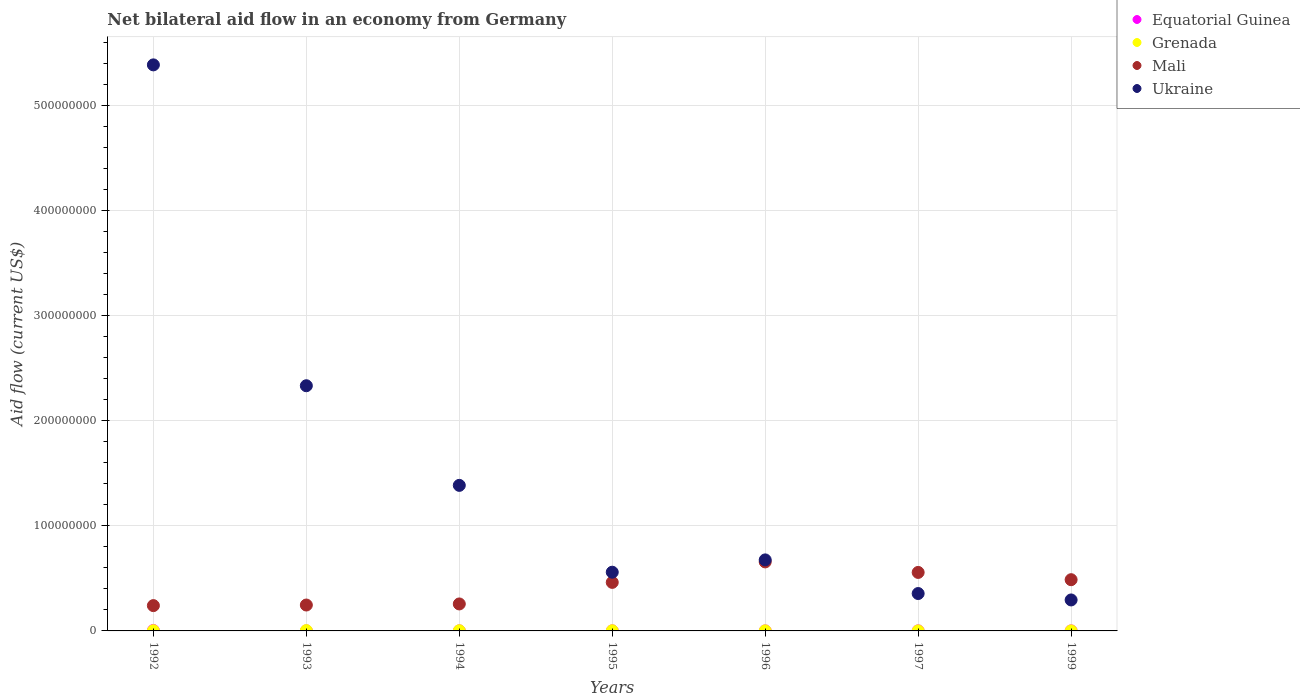Is the number of dotlines equal to the number of legend labels?
Ensure brevity in your answer.  Yes. What is the net bilateral aid flow in Equatorial Guinea in 1992?
Provide a short and direct response. 4.50e+05. In which year was the net bilateral aid flow in Ukraine minimum?
Provide a succinct answer. 1999. What is the total net bilateral aid flow in Ukraine in the graph?
Give a very brief answer. 1.10e+09. What is the difference between the net bilateral aid flow in Mali in 1992 and that in 1995?
Offer a very short reply. -2.21e+07. What is the difference between the net bilateral aid flow in Ukraine in 1994 and the net bilateral aid flow in Equatorial Guinea in 1996?
Give a very brief answer. 1.39e+08. What is the average net bilateral aid flow in Ukraine per year?
Your response must be concise. 1.57e+08. In the year 1993, what is the difference between the net bilateral aid flow in Equatorial Guinea and net bilateral aid flow in Mali?
Provide a succinct answer. -2.46e+07. In how many years, is the net bilateral aid flow in Equatorial Guinea greater than 380000000 US$?
Ensure brevity in your answer.  0. Is the difference between the net bilateral aid flow in Equatorial Guinea in 1994 and 1997 greater than the difference between the net bilateral aid flow in Mali in 1994 and 1997?
Give a very brief answer. Yes. What is the difference between the highest and the second highest net bilateral aid flow in Ukraine?
Your response must be concise. 3.05e+08. What is the difference between the highest and the lowest net bilateral aid flow in Ukraine?
Your response must be concise. 5.09e+08. In how many years, is the net bilateral aid flow in Ukraine greater than the average net bilateral aid flow in Ukraine taken over all years?
Ensure brevity in your answer.  2. Is it the case that in every year, the sum of the net bilateral aid flow in Equatorial Guinea and net bilateral aid flow in Mali  is greater than the sum of net bilateral aid flow in Grenada and net bilateral aid flow in Ukraine?
Provide a short and direct response. No. Does the net bilateral aid flow in Ukraine monotonically increase over the years?
Offer a very short reply. No. Is the net bilateral aid flow in Ukraine strictly less than the net bilateral aid flow in Equatorial Guinea over the years?
Make the answer very short. No. How many years are there in the graph?
Keep it short and to the point. 7. What is the difference between two consecutive major ticks on the Y-axis?
Offer a terse response. 1.00e+08. Where does the legend appear in the graph?
Give a very brief answer. Top right. What is the title of the graph?
Provide a short and direct response. Net bilateral aid flow in an economy from Germany. Does "Tajikistan" appear as one of the legend labels in the graph?
Your answer should be very brief. No. What is the Aid flow (current US$) in Mali in 1992?
Offer a very short reply. 2.41e+07. What is the Aid flow (current US$) in Ukraine in 1992?
Provide a short and direct response. 5.39e+08. What is the Aid flow (current US$) in Equatorial Guinea in 1993?
Provide a short and direct response. 5.00e+04. What is the Aid flow (current US$) of Grenada in 1993?
Provide a short and direct response. 3.10e+05. What is the Aid flow (current US$) of Mali in 1993?
Your response must be concise. 2.46e+07. What is the Aid flow (current US$) in Ukraine in 1993?
Offer a terse response. 2.33e+08. What is the Aid flow (current US$) in Equatorial Guinea in 1994?
Ensure brevity in your answer.  6.00e+04. What is the Aid flow (current US$) of Grenada in 1994?
Offer a terse response. 1.90e+05. What is the Aid flow (current US$) in Mali in 1994?
Make the answer very short. 2.57e+07. What is the Aid flow (current US$) of Ukraine in 1994?
Keep it short and to the point. 1.39e+08. What is the Aid flow (current US$) in Grenada in 1995?
Keep it short and to the point. 1.70e+05. What is the Aid flow (current US$) of Mali in 1995?
Your answer should be very brief. 4.62e+07. What is the Aid flow (current US$) in Ukraine in 1995?
Make the answer very short. 5.59e+07. What is the Aid flow (current US$) in Mali in 1996?
Your answer should be compact. 6.57e+07. What is the Aid flow (current US$) of Ukraine in 1996?
Give a very brief answer. 6.76e+07. What is the Aid flow (current US$) of Equatorial Guinea in 1997?
Make the answer very short. 7.00e+04. What is the Aid flow (current US$) of Grenada in 1997?
Your answer should be very brief. 3.00e+04. What is the Aid flow (current US$) in Mali in 1997?
Your response must be concise. 5.57e+07. What is the Aid flow (current US$) in Ukraine in 1997?
Offer a terse response. 3.56e+07. What is the Aid flow (current US$) in Mali in 1999?
Give a very brief answer. 4.88e+07. What is the Aid flow (current US$) in Ukraine in 1999?
Offer a very short reply. 2.95e+07. Across all years, what is the maximum Aid flow (current US$) of Grenada?
Your answer should be compact. 3.10e+05. Across all years, what is the maximum Aid flow (current US$) in Mali?
Make the answer very short. 6.57e+07. Across all years, what is the maximum Aid flow (current US$) in Ukraine?
Make the answer very short. 5.39e+08. Across all years, what is the minimum Aid flow (current US$) in Equatorial Guinea?
Your response must be concise. 3.00e+04. Across all years, what is the minimum Aid flow (current US$) in Mali?
Your answer should be compact. 2.41e+07. Across all years, what is the minimum Aid flow (current US$) in Ukraine?
Your answer should be very brief. 2.95e+07. What is the total Aid flow (current US$) in Equatorial Guinea in the graph?
Give a very brief answer. 7.90e+05. What is the total Aid flow (current US$) in Grenada in the graph?
Keep it short and to the point. 1.00e+06. What is the total Aid flow (current US$) of Mali in the graph?
Offer a very short reply. 2.91e+08. What is the total Aid flow (current US$) in Ukraine in the graph?
Offer a terse response. 1.10e+09. What is the difference between the Aid flow (current US$) of Mali in 1992 and that in 1993?
Your answer should be very brief. -5.60e+05. What is the difference between the Aid flow (current US$) in Ukraine in 1992 and that in 1993?
Your response must be concise. 3.05e+08. What is the difference between the Aid flow (current US$) of Equatorial Guinea in 1992 and that in 1994?
Give a very brief answer. 3.90e+05. What is the difference between the Aid flow (current US$) of Mali in 1992 and that in 1994?
Your answer should be very brief. -1.59e+06. What is the difference between the Aid flow (current US$) in Ukraine in 1992 and that in 1994?
Make the answer very short. 4.00e+08. What is the difference between the Aid flow (current US$) of Equatorial Guinea in 1992 and that in 1995?
Offer a very short reply. 3.80e+05. What is the difference between the Aid flow (current US$) of Grenada in 1992 and that in 1995?
Keep it short and to the point. 3.00e+04. What is the difference between the Aid flow (current US$) in Mali in 1992 and that in 1995?
Give a very brief answer. -2.21e+07. What is the difference between the Aid flow (current US$) in Ukraine in 1992 and that in 1995?
Provide a succinct answer. 4.83e+08. What is the difference between the Aid flow (current US$) of Mali in 1992 and that in 1996?
Ensure brevity in your answer.  -4.16e+07. What is the difference between the Aid flow (current US$) of Ukraine in 1992 and that in 1996?
Your response must be concise. 4.71e+08. What is the difference between the Aid flow (current US$) of Mali in 1992 and that in 1997?
Ensure brevity in your answer.  -3.16e+07. What is the difference between the Aid flow (current US$) in Ukraine in 1992 and that in 1997?
Ensure brevity in your answer.  5.03e+08. What is the difference between the Aid flow (current US$) in Equatorial Guinea in 1992 and that in 1999?
Make the answer very short. 3.90e+05. What is the difference between the Aid flow (current US$) in Mali in 1992 and that in 1999?
Provide a short and direct response. -2.47e+07. What is the difference between the Aid flow (current US$) of Ukraine in 1992 and that in 1999?
Offer a very short reply. 5.09e+08. What is the difference between the Aid flow (current US$) in Equatorial Guinea in 1993 and that in 1994?
Give a very brief answer. -10000. What is the difference between the Aid flow (current US$) in Mali in 1993 and that in 1994?
Your response must be concise. -1.03e+06. What is the difference between the Aid flow (current US$) of Ukraine in 1993 and that in 1994?
Keep it short and to the point. 9.48e+07. What is the difference between the Aid flow (current US$) in Equatorial Guinea in 1993 and that in 1995?
Offer a very short reply. -2.00e+04. What is the difference between the Aid flow (current US$) of Grenada in 1993 and that in 1995?
Provide a succinct answer. 1.40e+05. What is the difference between the Aid flow (current US$) in Mali in 1993 and that in 1995?
Keep it short and to the point. -2.16e+07. What is the difference between the Aid flow (current US$) in Ukraine in 1993 and that in 1995?
Keep it short and to the point. 1.77e+08. What is the difference between the Aid flow (current US$) in Equatorial Guinea in 1993 and that in 1996?
Offer a terse response. 2.00e+04. What is the difference between the Aid flow (current US$) of Grenada in 1993 and that in 1996?
Offer a terse response. 2.40e+05. What is the difference between the Aid flow (current US$) in Mali in 1993 and that in 1996?
Provide a succinct answer. -4.10e+07. What is the difference between the Aid flow (current US$) in Ukraine in 1993 and that in 1996?
Your response must be concise. 1.66e+08. What is the difference between the Aid flow (current US$) of Equatorial Guinea in 1993 and that in 1997?
Offer a terse response. -2.00e+04. What is the difference between the Aid flow (current US$) in Grenada in 1993 and that in 1997?
Keep it short and to the point. 2.80e+05. What is the difference between the Aid flow (current US$) of Mali in 1993 and that in 1997?
Keep it short and to the point. -3.10e+07. What is the difference between the Aid flow (current US$) of Ukraine in 1993 and that in 1997?
Make the answer very short. 1.98e+08. What is the difference between the Aid flow (current US$) in Grenada in 1993 and that in 1999?
Give a very brief answer. 2.80e+05. What is the difference between the Aid flow (current US$) in Mali in 1993 and that in 1999?
Your answer should be very brief. -2.41e+07. What is the difference between the Aid flow (current US$) in Ukraine in 1993 and that in 1999?
Offer a very short reply. 2.04e+08. What is the difference between the Aid flow (current US$) in Mali in 1994 and that in 1995?
Give a very brief answer. -2.05e+07. What is the difference between the Aid flow (current US$) of Ukraine in 1994 and that in 1995?
Your answer should be compact. 8.27e+07. What is the difference between the Aid flow (current US$) in Equatorial Guinea in 1994 and that in 1996?
Your answer should be compact. 3.00e+04. What is the difference between the Aid flow (current US$) in Mali in 1994 and that in 1996?
Your answer should be compact. -4.00e+07. What is the difference between the Aid flow (current US$) in Ukraine in 1994 and that in 1996?
Keep it short and to the point. 7.09e+07. What is the difference between the Aid flow (current US$) in Mali in 1994 and that in 1997?
Offer a very short reply. -3.00e+07. What is the difference between the Aid flow (current US$) of Ukraine in 1994 and that in 1997?
Make the answer very short. 1.03e+08. What is the difference between the Aid flow (current US$) in Equatorial Guinea in 1994 and that in 1999?
Give a very brief answer. 0. What is the difference between the Aid flow (current US$) in Mali in 1994 and that in 1999?
Your response must be concise. -2.31e+07. What is the difference between the Aid flow (current US$) in Ukraine in 1994 and that in 1999?
Give a very brief answer. 1.09e+08. What is the difference between the Aid flow (current US$) in Equatorial Guinea in 1995 and that in 1996?
Your response must be concise. 4.00e+04. What is the difference between the Aid flow (current US$) in Mali in 1995 and that in 1996?
Offer a very short reply. -1.95e+07. What is the difference between the Aid flow (current US$) in Ukraine in 1995 and that in 1996?
Ensure brevity in your answer.  -1.17e+07. What is the difference between the Aid flow (current US$) of Equatorial Guinea in 1995 and that in 1997?
Keep it short and to the point. 0. What is the difference between the Aid flow (current US$) of Mali in 1995 and that in 1997?
Offer a terse response. -9.48e+06. What is the difference between the Aid flow (current US$) in Ukraine in 1995 and that in 1997?
Ensure brevity in your answer.  2.03e+07. What is the difference between the Aid flow (current US$) of Grenada in 1995 and that in 1999?
Offer a terse response. 1.40e+05. What is the difference between the Aid flow (current US$) in Mali in 1995 and that in 1999?
Your response must be concise. -2.56e+06. What is the difference between the Aid flow (current US$) in Ukraine in 1995 and that in 1999?
Offer a very short reply. 2.64e+07. What is the difference between the Aid flow (current US$) in Grenada in 1996 and that in 1997?
Ensure brevity in your answer.  4.00e+04. What is the difference between the Aid flow (current US$) in Mali in 1996 and that in 1997?
Offer a very short reply. 1.00e+07. What is the difference between the Aid flow (current US$) of Ukraine in 1996 and that in 1997?
Give a very brief answer. 3.20e+07. What is the difference between the Aid flow (current US$) of Equatorial Guinea in 1996 and that in 1999?
Provide a succinct answer. -3.00e+04. What is the difference between the Aid flow (current US$) of Grenada in 1996 and that in 1999?
Your answer should be compact. 4.00e+04. What is the difference between the Aid flow (current US$) in Mali in 1996 and that in 1999?
Keep it short and to the point. 1.69e+07. What is the difference between the Aid flow (current US$) in Ukraine in 1996 and that in 1999?
Offer a terse response. 3.81e+07. What is the difference between the Aid flow (current US$) in Equatorial Guinea in 1997 and that in 1999?
Provide a succinct answer. 10000. What is the difference between the Aid flow (current US$) in Grenada in 1997 and that in 1999?
Keep it short and to the point. 0. What is the difference between the Aid flow (current US$) in Mali in 1997 and that in 1999?
Offer a very short reply. 6.92e+06. What is the difference between the Aid flow (current US$) of Ukraine in 1997 and that in 1999?
Provide a short and direct response. 6.10e+06. What is the difference between the Aid flow (current US$) of Equatorial Guinea in 1992 and the Aid flow (current US$) of Grenada in 1993?
Offer a terse response. 1.40e+05. What is the difference between the Aid flow (current US$) in Equatorial Guinea in 1992 and the Aid flow (current US$) in Mali in 1993?
Keep it short and to the point. -2.42e+07. What is the difference between the Aid flow (current US$) in Equatorial Guinea in 1992 and the Aid flow (current US$) in Ukraine in 1993?
Provide a short and direct response. -2.33e+08. What is the difference between the Aid flow (current US$) in Grenada in 1992 and the Aid flow (current US$) in Mali in 1993?
Make the answer very short. -2.44e+07. What is the difference between the Aid flow (current US$) of Grenada in 1992 and the Aid flow (current US$) of Ukraine in 1993?
Provide a succinct answer. -2.33e+08. What is the difference between the Aid flow (current US$) of Mali in 1992 and the Aid flow (current US$) of Ukraine in 1993?
Give a very brief answer. -2.09e+08. What is the difference between the Aid flow (current US$) of Equatorial Guinea in 1992 and the Aid flow (current US$) of Mali in 1994?
Ensure brevity in your answer.  -2.52e+07. What is the difference between the Aid flow (current US$) in Equatorial Guinea in 1992 and the Aid flow (current US$) in Ukraine in 1994?
Make the answer very short. -1.38e+08. What is the difference between the Aid flow (current US$) of Grenada in 1992 and the Aid flow (current US$) of Mali in 1994?
Give a very brief answer. -2.55e+07. What is the difference between the Aid flow (current US$) of Grenada in 1992 and the Aid flow (current US$) of Ukraine in 1994?
Your answer should be very brief. -1.38e+08. What is the difference between the Aid flow (current US$) of Mali in 1992 and the Aid flow (current US$) of Ukraine in 1994?
Provide a short and direct response. -1.14e+08. What is the difference between the Aid flow (current US$) in Equatorial Guinea in 1992 and the Aid flow (current US$) in Grenada in 1995?
Provide a succinct answer. 2.80e+05. What is the difference between the Aid flow (current US$) of Equatorial Guinea in 1992 and the Aid flow (current US$) of Mali in 1995?
Provide a short and direct response. -4.58e+07. What is the difference between the Aid flow (current US$) of Equatorial Guinea in 1992 and the Aid flow (current US$) of Ukraine in 1995?
Your answer should be compact. -5.54e+07. What is the difference between the Aid flow (current US$) of Grenada in 1992 and the Aid flow (current US$) of Mali in 1995?
Offer a terse response. -4.60e+07. What is the difference between the Aid flow (current US$) of Grenada in 1992 and the Aid flow (current US$) of Ukraine in 1995?
Offer a terse response. -5.57e+07. What is the difference between the Aid flow (current US$) in Mali in 1992 and the Aid flow (current US$) in Ukraine in 1995?
Your answer should be compact. -3.18e+07. What is the difference between the Aid flow (current US$) of Equatorial Guinea in 1992 and the Aid flow (current US$) of Grenada in 1996?
Your answer should be compact. 3.80e+05. What is the difference between the Aid flow (current US$) in Equatorial Guinea in 1992 and the Aid flow (current US$) in Mali in 1996?
Your answer should be compact. -6.52e+07. What is the difference between the Aid flow (current US$) in Equatorial Guinea in 1992 and the Aid flow (current US$) in Ukraine in 1996?
Your answer should be very brief. -6.72e+07. What is the difference between the Aid flow (current US$) in Grenada in 1992 and the Aid flow (current US$) in Mali in 1996?
Make the answer very short. -6.55e+07. What is the difference between the Aid flow (current US$) in Grenada in 1992 and the Aid flow (current US$) in Ukraine in 1996?
Ensure brevity in your answer.  -6.74e+07. What is the difference between the Aid flow (current US$) in Mali in 1992 and the Aid flow (current US$) in Ukraine in 1996?
Offer a terse response. -4.35e+07. What is the difference between the Aid flow (current US$) in Equatorial Guinea in 1992 and the Aid flow (current US$) in Grenada in 1997?
Provide a succinct answer. 4.20e+05. What is the difference between the Aid flow (current US$) of Equatorial Guinea in 1992 and the Aid flow (current US$) of Mali in 1997?
Ensure brevity in your answer.  -5.52e+07. What is the difference between the Aid flow (current US$) of Equatorial Guinea in 1992 and the Aid flow (current US$) of Ukraine in 1997?
Your answer should be very brief. -3.51e+07. What is the difference between the Aid flow (current US$) of Grenada in 1992 and the Aid flow (current US$) of Mali in 1997?
Offer a very short reply. -5.55e+07. What is the difference between the Aid flow (current US$) in Grenada in 1992 and the Aid flow (current US$) in Ukraine in 1997?
Your answer should be compact. -3.54e+07. What is the difference between the Aid flow (current US$) in Mali in 1992 and the Aid flow (current US$) in Ukraine in 1997?
Your answer should be very brief. -1.15e+07. What is the difference between the Aid flow (current US$) of Equatorial Guinea in 1992 and the Aid flow (current US$) of Grenada in 1999?
Give a very brief answer. 4.20e+05. What is the difference between the Aid flow (current US$) in Equatorial Guinea in 1992 and the Aid flow (current US$) in Mali in 1999?
Ensure brevity in your answer.  -4.83e+07. What is the difference between the Aid flow (current US$) of Equatorial Guinea in 1992 and the Aid flow (current US$) of Ukraine in 1999?
Offer a very short reply. -2.90e+07. What is the difference between the Aid flow (current US$) of Grenada in 1992 and the Aid flow (current US$) of Mali in 1999?
Your response must be concise. -4.86e+07. What is the difference between the Aid flow (current US$) in Grenada in 1992 and the Aid flow (current US$) in Ukraine in 1999?
Give a very brief answer. -2.93e+07. What is the difference between the Aid flow (current US$) of Mali in 1992 and the Aid flow (current US$) of Ukraine in 1999?
Ensure brevity in your answer.  -5.40e+06. What is the difference between the Aid flow (current US$) in Equatorial Guinea in 1993 and the Aid flow (current US$) in Grenada in 1994?
Make the answer very short. -1.40e+05. What is the difference between the Aid flow (current US$) in Equatorial Guinea in 1993 and the Aid flow (current US$) in Mali in 1994?
Your answer should be compact. -2.56e+07. What is the difference between the Aid flow (current US$) in Equatorial Guinea in 1993 and the Aid flow (current US$) in Ukraine in 1994?
Your response must be concise. -1.38e+08. What is the difference between the Aid flow (current US$) in Grenada in 1993 and the Aid flow (current US$) in Mali in 1994?
Ensure brevity in your answer.  -2.54e+07. What is the difference between the Aid flow (current US$) of Grenada in 1993 and the Aid flow (current US$) of Ukraine in 1994?
Your answer should be very brief. -1.38e+08. What is the difference between the Aid flow (current US$) in Mali in 1993 and the Aid flow (current US$) in Ukraine in 1994?
Give a very brief answer. -1.14e+08. What is the difference between the Aid flow (current US$) of Equatorial Guinea in 1993 and the Aid flow (current US$) of Mali in 1995?
Keep it short and to the point. -4.62e+07. What is the difference between the Aid flow (current US$) of Equatorial Guinea in 1993 and the Aid flow (current US$) of Ukraine in 1995?
Your answer should be compact. -5.58e+07. What is the difference between the Aid flow (current US$) of Grenada in 1993 and the Aid flow (current US$) of Mali in 1995?
Provide a short and direct response. -4.59e+07. What is the difference between the Aid flow (current US$) of Grenada in 1993 and the Aid flow (current US$) of Ukraine in 1995?
Your response must be concise. -5.56e+07. What is the difference between the Aid flow (current US$) in Mali in 1993 and the Aid flow (current US$) in Ukraine in 1995?
Offer a very short reply. -3.12e+07. What is the difference between the Aid flow (current US$) in Equatorial Guinea in 1993 and the Aid flow (current US$) in Grenada in 1996?
Your answer should be very brief. -2.00e+04. What is the difference between the Aid flow (current US$) in Equatorial Guinea in 1993 and the Aid flow (current US$) in Mali in 1996?
Your answer should be compact. -6.56e+07. What is the difference between the Aid flow (current US$) of Equatorial Guinea in 1993 and the Aid flow (current US$) of Ukraine in 1996?
Ensure brevity in your answer.  -6.76e+07. What is the difference between the Aid flow (current US$) of Grenada in 1993 and the Aid flow (current US$) of Mali in 1996?
Give a very brief answer. -6.54e+07. What is the difference between the Aid flow (current US$) of Grenada in 1993 and the Aid flow (current US$) of Ukraine in 1996?
Offer a very short reply. -6.73e+07. What is the difference between the Aid flow (current US$) in Mali in 1993 and the Aid flow (current US$) in Ukraine in 1996?
Make the answer very short. -4.30e+07. What is the difference between the Aid flow (current US$) in Equatorial Guinea in 1993 and the Aid flow (current US$) in Mali in 1997?
Make the answer very short. -5.56e+07. What is the difference between the Aid flow (current US$) of Equatorial Guinea in 1993 and the Aid flow (current US$) of Ukraine in 1997?
Ensure brevity in your answer.  -3.55e+07. What is the difference between the Aid flow (current US$) of Grenada in 1993 and the Aid flow (current US$) of Mali in 1997?
Provide a short and direct response. -5.54e+07. What is the difference between the Aid flow (current US$) in Grenada in 1993 and the Aid flow (current US$) in Ukraine in 1997?
Provide a short and direct response. -3.53e+07. What is the difference between the Aid flow (current US$) in Mali in 1993 and the Aid flow (current US$) in Ukraine in 1997?
Your response must be concise. -1.09e+07. What is the difference between the Aid flow (current US$) of Equatorial Guinea in 1993 and the Aid flow (current US$) of Grenada in 1999?
Your answer should be compact. 2.00e+04. What is the difference between the Aid flow (current US$) of Equatorial Guinea in 1993 and the Aid flow (current US$) of Mali in 1999?
Make the answer very short. -4.87e+07. What is the difference between the Aid flow (current US$) in Equatorial Guinea in 1993 and the Aid flow (current US$) in Ukraine in 1999?
Provide a short and direct response. -2.94e+07. What is the difference between the Aid flow (current US$) in Grenada in 1993 and the Aid flow (current US$) in Mali in 1999?
Make the answer very short. -4.84e+07. What is the difference between the Aid flow (current US$) in Grenada in 1993 and the Aid flow (current US$) in Ukraine in 1999?
Offer a terse response. -2.92e+07. What is the difference between the Aid flow (current US$) in Mali in 1993 and the Aid flow (current US$) in Ukraine in 1999?
Your answer should be compact. -4.84e+06. What is the difference between the Aid flow (current US$) in Equatorial Guinea in 1994 and the Aid flow (current US$) in Mali in 1995?
Provide a succinct answer. -4.61e+07. What is the difference between the Aid flow (current US$) in Equatorial Guinea in 1994 and the Aid flow (current US$) in Ukraine in 1995?
Keep it short and to the point. -5.58e+07. What is the difference between the Aid flow (current US$) in Grenada in 1994 and the Aid flow (current US$) in Mali in 1995?
Give a very brief answer. -4.60e+07. What is the difference between the Aid flow (current US$) in Grenada in 1994 and the Aid flow (current US$) in Ukraine in 1995?
Ensure brevity in your answer.  -5.57e+07. What is the difference between the Aid flow (current US$) of Mali in 1994 and the Aid flow (current US$) of Ukraine in 1995?
Offer a very short reply. -3.02e+07. What is the difference between the Aid flow (current US$) in Equatorial Guinea in 1994 and the Aid flow (current US$) in Grenada in 1996?
Provide a short and direct response. -10000. What is the difference between the Aid flow (current US$) of Equatorial Guinea in 1994 and the Aid flow (current US$) of Mali in 1996?
Your answer should be compact. -6.56e+07. What is the difference between the Aid flow (current US$) in Equatorial Guinea in 1994 and the Aid flow (current US$) in Ukraine in 1996?
Provide a short and direct response. -6.76e+07. What is the difference between the Aid flow (current US$) of Grenada in 1994 and the Aid flow (current US$) of Mali in 1996?
Make the answer very short. -6.55e+07. What is the difference between the Aid flow (current US$) of Grenada in 1994 and the Aid flow (current US$) of Ukraine in 1996?
Keep it short and to the point. -6.74e+07. What is the difference between the Aid flow (current US$) of Mali in 1994 and the Aid flow (current US$) of Ukraine in 1996?
Provide a succinct answer. -4.19e+07. What is the difference between the Aid flow (current US$) of Equatorial Guinea in 1994 and the Aid flow (current US$) of Mali in 1997?
Keep it short and to the point. -5.56e+07. What is the difference between the Aid flow (current US$) of Equatorial Guinea in 1994 and the Aid flow (current US$) of Ukraine in 1997?
Provide a short and direct response. -3.55e+07. What is the difference between the Aid flow (current US$) in Grenada in 1994 and the Aid flow (current US$) in Mali in 1997?
Offer a very short reply. -5.55e+07. What is the difference between the Aid flow (current US$) of Grenada in 1994 and the Aid flow (current US$) of Ukraine in 1997?
Your response must be concise. -3.54e+07. What is the difference between the Aid flow (current US$) of Mali in 1994 and the Aid flow (current US$) of Ukraine in 1997?
Your response must be concise. -9.91e+06. What is the difference between the Aid flow (current US$) in Equatorial Guinea in 1994 and the Aid flow (current US$) in Grenada in 1999?
Your response must be concise. 3.00e+04. What is the difference between the Aid flow (current US$) of Equatorial Guinea in 1994 and the Aid flow (current US$) of Mali in 1999?
Keep it short and to the point. -4.87e+07. What is the difference between the Aid flow (current US$) of Equatorial Guinea in 1994 and the Aid flow (current US$) of Ukraine in 1999?
Provide a succinct answer. -2.94e+07. What is the difference between the Aid flow (current US$) of Grenada in 1994 and the Aid flow (current US$) of Mali in 1999?
Your answer should be very brief. -4.86e+07. What is the difference between the Aid flow (current US$) of Grenada in 1994 and the Aid flow (current US$) of Ukraine in 1999?
Ensure brevity in your answer.  -2.93e+07. What is the difference between the Aid flow (current US$) in Mali in 1994 and the Aid flow (current US$) in Ukraine in 1999?
Keep it short and to the point. -3.81e+06. What is the difference between the Aid flow (current US$) of Equatorial Guinea in 1995 and the Aid flow (current US$) of Mali in 1996?
Offer a very short reply. -6.56e+07. What is the difference between the Aid flow (current US$) in Equatorial Guinea in 1995 and the Aid flow (current US$) in Ukraine in 1996?
Your response must be concise. -6.75e+07. What is the difference between the Aid flow (current US$) of Grenada in 1995 and the Aid flow (current US$) of Mali in 1996?
Your response must be concise. -6.55e+07. What is the difference between the Aid flow (current US$) of Grenada in 1995 and the Aid flow (current US$) of Ukraine in 1996?
Ensure brevity in your answer.  -6.74e+07. What is the difference between the Aid flow (current US$) of Mali in 1995 and the Aid flow (current US$) of Ukraine in 1996?
Your answer should be compact. -2.14e+07. What is the difference between the Aid flow (current US$) of Equatorial Guinea in 1995 and the Aid flow (current US$) of Grenada in 1997?
Provide a succinct answer. 4.00e+04. What is the difference between the Aid flow (current US$) of Equatorial Guinea in 1995 and the Aid flow (current US$) of Mali in 1997?
Your answer should be very brief. -5.56e+07. What is the difference between the Aid flow (current US$) in Equatorial Guinea in 1995 and the Aid flow (current US$) in Ukraine in 1997?
Provide a succinct answer. -3.55e+07. What is the difference between the Aid flow (current US$) of Grenada in 1995 and the Aid flow (current US$) of Mali in 1997?
Make the answer very short. -5.55e+07. What is the difference between the Aid flow (current US$) in Grenada in 1995 and the Aid flow (current US$) in Ukraine in 1997?
Ensure brevity in your answer.  -3.54e+07. What is the difference between the Aid flow (current US$) in Mali in 1995 and the Aid flow (current US$) in Ukraine in 1997?
Offer a very short reply. 1.06e+07. What is the difference between the Aid flow (current US$) in Equatorial Guinea in 1995 and the Aid flow (current US$) in Grenada in 1999?
Provide a short and direct response. 4.00e+04. What is the difference between the Aid flow (current US$) in Equatorial Guinea in 1995 and the Aid flow (current US$) in Mali in 1999?
Offer a very short reply. -4.87e+07. What is the difference between the Aid flow (current US$) of Equatorial Guinea in 1995 and the Aid flow (current US$) of Ukraine in 1999?
Offer a terse response. -2.94e+07. What is the difference between the Aid flow (current US$) in Grenada in 1995 and the Aid flow (current US$) in Mali in 1999?
Provide a short and direct response. -4.86e+07. What is the difference between the Aid flow (current US$) in Grenada in 1995 and the Aid flow (current US$) in Ukraine in 1999?
Make the answer very short. -2.93e+07. What is the difference between the Aid flow (current US$) of Mali in 1995 and the Aid flow (current US$) of Ukraine in 1999?
Provide a succinct answer. 1.67e+07. What is the difference between the Aid flow (current US$) of Equatorial Guinea in 1996 and the Aid flow (current US$) of Mali in 1997?
Make the answer very short. -5.56e+07. What is the difference between the Aid flow (current US$) in Equatorial Guinea in 1996 and the Aid flow (current US$) in Ukraine in 1997?
Keep it short and to the point. -3.56e+07. What is the difference between the Aid flow (current US$) of Grenada in 1996 and the Aid flow (current US$) of Mali in 1997?
Keep it short and to the point. -5.56e+07. What is the difference between the Aid flow (current US$) of Grenada in 1996 and the Aid flow (current US$) of Ukraine in 1997?
Provide a short and direct response. -3.55e+07. What is the difference between the Aid flow (current US$) of Mali in 1996 and the Aid flow (current US$) of Ukraine in 1997?
Offer a terse response. 3.01e+07. What is the difference between the Aid flow (current US$) in Equatorial Guinea in 1996 and the Aid flow (current US$) in Mali in 1999?
Provide a succinct answer. -4.87e+07. What is the difference between the Aid flow (current US$) of Equatorial Guinea in 1996 and the Aid flow (current US$) of Ukraine in 1999?
Make the answer very short. -2.95e+07. What is the difference between the Aid flow (current US$) in Grenada in 1996 and the Aid flow (current US$) in Mali in 1999?
Keep it short and to the point. -4.87e+07. What is the difference between the Aid flow (current US$) in Grenada in 1996 and the Aid flow (current US$) in Ukraine in 1999?
Keep it short and to the point. -2.94e+07. What is the difference between the Aid flow (current US$) in Mali in 1996 and the Aid flow (current US$) in Ukraine in 1999?
Offer a very short reply. 3.62e+07. What is the difference between the Aid flow (current US$) of Equatorial Guinea in 1997 and the Aid flow (current US$) of Mali in 1999?
Your response must be concise. -4.87e+07. What is the difference between the Aid flow (current US$) of Equatorial Guinea in 1997 and the Aid flow (current US$) of Ukraine in 1999?
Make the answer very short. -2.94e+07. What is the difference between the Aid flow (current US$) of Grenada in 1997 and the Aid flow (current US$) of Mali in 1999?
Your answer should be compact. -4.87e+07. What is the difference between the Aid flow (current US$) of Grenada in 1997 and the Aid flow (current US$) of Ukraine in 1999?
Your answer should be very brief. -2.95e+07. What is the difference between the Aid flow (current US$) of Mali in 1997 and the Aid flow (current US$) of Ukraine in 1999?
Provide a succinct answer. 2.62e+07. What is the average Aid flow (current US$) of Equatorial Guinea per year?
Your answer should be compact. 1.13e+05. What is the average Aid flow (current US$) in Grenada per year?
Provide a succinct answer. 1.43e+05. What is the average Aid flow (current US$) in Mali per year?
Make the answer very short. 4.15e+07. What is the average Aid flow (current US$) in Ukraine per year?
Give a very brief answer. 1.57e+08. In the year 1992, what is the difference between the Aid flow (current US$) of Equatorial Guinea and Aid flow (current US$) of Mali?
Ensure brevity in your answer.  -2.36e+07. In the year 1992, what is the difference between the Aid flow (current US$) in Equatorial Guinea and Aid flow (current US$) in Ukraine?
Keep it short and to the point. -5.38e+08. In the year 1992, what is the difference between the Aid flow (current US$) of Grenada and Aid flow (current US$) of Mali?
Offer a terse response. -2.39e+07. In the year 1992, what is the difference between the Aid flow (current US$) of Grenada and Aid flow (current US$) of Ukraine?
Offer a terse response. -5.39e+08. In the year 1992, what is the difference between the Aid flow (current US$) in Mali and Aid flow (current US$) in Ukraine?
Make the answer very short. -5.15e+08. In the year 1993, what is the difference between the Aid flow (current US$) in Equatorial Guinea and Aid flow (current US$) in Grenada?
Your answer should be very brief. -2.60e+05. In the year 1993, what is the difference between the Aid flow (current US$) of Equatorial Guinea and Aid flow (current US$) of Mali?
Offer a terse response. -2.46e+07. In the year 1993, what is the difference between the Aid flow (current US$) in Equatorial Guinea and Aid flow (current US$) in Ukraine?
Your answer should be very brief. -2.33e+08. In the year 1993, what is the difference between the Aid flow (current US$) of Grenada and Aid flow (current US$) of Mali?
Your response must be concise. -2.43e+07. In the year 1993, what is the difference between the Aid flow (current US$) in Grenada and Aid flow (current US$) in Ukraine?
Make the answer very short. -2.33e+08. In the year 1993, what is the difference between the Aid flow (current US$) of Mali and Aid flow (current US$) of Ukraine?
Provide a short and direct response. -2.09e+08. In the year 1994, what is the difference between the Aid flow (current US$) of Equatorial Guinea and Aid flow (current US$) of Grenada?
Offer a terse response. -1.30e+05. In the year 1994, what is the difference between the Aid flow (current US$) of Equatorial Guinea and Aid flow (current US$) of Mali?
Offer a terse response. -2.56e+07. In the year 1994, what is the difference between the Aid flow (current US$) of Equatorial Guinea and Aid flow (current US$) of Ukraine?
Provide a succinct answer. -1.38e+08. In the year 1994, what is the difference between the Aid flow (current US$) in Grenada and Aid flow (current US$) in Mali?
Offer a very short reply. -2.55e+07. In the year 1994, what is the difference between the Aid flow (current US$) in Grenada and Aid flow (current US$) in Ukraine?
Your response must be concise. -1.38e+08. In the year 1994, what is the difference between the Aid flow (current US$) in Mali and Aid flow (current US$) in Ukraine?
Keep it short and to the point. -1.13e+08. In the year 1995, what is the difference between the Aid flow (current US$) of Equatorial Guinea and Aid flow (current US$) of Mali?
Ensure brevity in your answer.  -4.61e+07. In the year 1995, what is the difference between the Aid flow (current US$) in Equatorial Guinea and Aid flow (current US$) in Ukraine?
Make the answer very short. -5.58e+07. In the year 1995, what is the difference between the Aid flow (current US$) in Grenada and Aid flow (current US$) in Mali?
Provide a succinct answer. -4.60e+07. In the year 1995, what is the difference between the Aid flow (current US$) of Grenada and Aid flow (current US$) of Ukraine?
Ensure brevity in your answer.  -5.57e+07. In the year 1995, what is the difference between the Aid flow (current US$) in Mali and Aid flow (current US$) in Ukraine?
Keep it short and to the point. -9.69e+06. In the year 1996, what is the difference between the Aid flow (current US$) in Equatorial Guinea and Aid flow (current US$) in Grenada?
Provide a succinct answer. -4.00e+04. In the year 1996, what is the difference between the Aid flow (current US$) of Equatorial Guinea and Aid flow (current US$) of Mali?
Give a very brief answer. -6.57e+07. In the year 1996, what is the difference between the Aid flow (current US$) of Equatorial Guinea and Aid flow (current US$) of Ukraine?
Keep it short and to the point. -6.76e+07. In the year 1996, what is the difference between the Aid flow (current US$) in Grenada and Aid flow (current US$) in Mali?
Give a very brief answer. -6.56e+07. In the year 1996, what is the difference between the Aid flow (current US$) in Grenada and Aid flow (current US$) in Ukraine?
Offer a terse response. -6.75e+07. In the year 1996, what is the difference between the Aid flow (current US$) in Mali and Aid flow (current US$) in Ukraine?
Your answer should be compact. -1.92e+06. In the year 1997, what is the difference between the Aid flow (current US$) in Equatorial Guinea and Aid flow (current US$) in Mali?
Your response must be concise. -5.56e+07. In the year 1997, what is the difference between the Aid flow (current US$) of Equatorial Guinea and Aid flow (current US$) of Ukraine?
Make the answer very short. -3.55e+07. In the year 1997, what is the difference between the Aid flow (current US$) of Grenada and Aid flow (current US$) of Mali?
Keep it short and to the point. -5.56e+07. In the year 1997, what is the difference between the Aid flow (current US$) in Grenada and Aid flow (current US$) in Ukraine?
Make the answer very short. -3.56e+07. In the year 1997, what is the difference between the Aid flow (current US$) in Mali and Aid flow (current US$) in Ukraine?
Ensure brevity in your answer.  2.01e+07. In the year 1999, what is the difference between the Aid flow (current US$) of Equatorial Guinea and Aid flow (current US$) of Mali?
Provide a short and direct response. -4.87e+07. In the year 1999, what is the difference between the Aid flow (current US$) in Equatorial Guinea and Aid flow (current US$) in Ukraine?
Make the answer very short. -2.94e+07. In the year 1999, what is the difference between the Aid flow (current US$) of Grenada and Aid flow (current US$) of Mali?
Your answer should be very brief. -4.87e+07. In the year 1999, what is the difference between the Aid flow (current US$) in Grenada and Aid flow (current US$) in Ukraine?
Provide a short and direct response. -2.95e+07. In the year 1999, what is the difference between the Aid flow (current US$) of Mali and Aid flow (current US$) of Ukraine?
Give a very brief answer. 1.93e+07. What is the ratio of the Aid flow (current US$) in Equatorial Guinea in 1992 to that in 1993?
Your answer should be very brief. 9. What is the ratio of the Aid flow (current US$) of Grenada in 1992 to that in 1993?
Make the answer very short. 0.65. What is the ratio of the Aid flow (current US$) in Mali in 1992 to that in 1993?
Keep it short and to the point. 0.98. What is the ratio of the Aid flow (current US$) of Ukraine in 1992 to that in 1993?
Keep it short and to the point. 2.31. What is the ratio of the Aid flow (current US$) of Equatorial Guinea in 1992 to that in 1994?
Your response must be concise. 7.5. What is the ratio of the Aid flow (current US$) in Grenada in 1992 to that in 1994?
Ensure brevity in your answer.  1.05. What is the ratio of the Aid flow (current US$) in Mali in 1992 to that in 1994?
Keep it short and to the point. 0.94. What is the ratio of the Aid flow (current US$) in Ukraine in 1992 to that in 1994?
Ensure brevity in your answer.  3.89. What is the ratio of the Aid flow (current US$) in Equatorial Guinea in 1992 to that in 1995?
Ensure brevity in your answer.  6.43. What is the ratio of the Aid flow (current US$) in Grenada in 1992 to that in 1995?
Your answer should be compact. 1.18. What is the ratio of the Aid flow (current US$) of Mali in 1992 to that in 1995?
Provide a short and direct response. 0.52. What is the ratio of the Aid flow (current US$) in Ukraine in 1992 to that in 1995?
Your answer should be very brief. 9.64. What is the ratio of the Aid flow (current US$) in Grenada in 1992 to that in 1996?
Provide a succinct answer. 2.86. What is the ratio of the Aid flow (current US$) in Mali in 1992 to that in 1996?
Make the answer very short. 0.37. What is the ratio of the Aid flow (current US$) in Ukraine in 1992 to that in 1996?
Ensure brevity in your answer.  7.97. What is the ratio of the Aid flow (current US$) of Equatorial Guinea in 1992 to that in 1997?
Your answer should be very brief. 6.43. What is the ratio of the Aid flow (current US$) of Grenada in 1992 to that in 1997?
Your response must be concise. 6.67. What is the ratio of the Aid flow (current US$) of Mali in 1992 to that in 1997?
Your answer should be very brief. 0.43. What is the ratio of the Aid flow (current US$) of Ukraine in 1992 to that in 1997?
Provide a short and direct response. 15.14. What is the ratio of the Aid flow (current US$) in Equatorial Guinea in 1992 to that in 1999?
Give a very brief answer. 7.5. What is the ratio of the Aid flow (current US$) of Mali in 1992 to that in 1999?
Your response must be concise. 0.49. What is the ratio of the Aid flow (current US$) of Ukraine in 1992 to that in 1999?
Provide a short and direct response. 18.27. What is the ratio of the Aid flow (current US$) in Grenada in 1993 to that in 1994?
Offer a terse response. 1.63. What is the ratio of the Aid flow (current US$) of Mali in 1993 to that in 1994?
Your answer should be compact. 0.96. What is the ratio of the Aid flow (current US$) of Ukraine in 1993 to that in 1994?
Offer a very short reply. 1.68. What is the ratio of the Aid flow (current US$) in Equatorial Guinea in 1993 to that in 1995?
Keep it short and to the point. 0.71. What is the ratio of the Aid flow (current US$) of Grenada in 1993 to that in 1995?
Offer a very short reply. 1.82. What is the ratio of the Aid flow (current US$) in Mali in 1993 to that in 1995?
Your answer should be very brief. 0.53. What is the ratio of the Aid flow (current US$) in Ukraine in 1993 to that in 1995?
Offer a very short reply. 4.18. What is the ratio of the Aid flow (current US$) in Equatorial Guinea in 1993 to that in 1996?
Ensure brevity in your answer.  1.67. What is the ratio of the Aid flow (current US$) of Grenada in 1993 to that in 1996?
Your answer should be compact. 4.43. What is the ratio of the Aid flow (current US$) in Mali in 1993 to that in 1996?
Ensure brevity in your answer.  0.38. What is the ratio of the Aid flow (current US$) in Ukraine in 1993 to that in 1996?
Ensure brevity in your answer.  3.45. What is the ratio of the Aid flow (current US$) in Grenada in 1993 to that in 1997?
Keep it short and to the point. 10.33. What is the ratio of the Aid flow (current US$) of Mali in 1993 to that in 1997?
Provide a succinct answer. 0.44. What is the ratio of the Aid flow (current US$) in Ukraine in 1993 to that in 1997?
Offer a very short reply. 6.56. What is the ratio of the Aid flow (current US$) of Grenada in 1993 to that in 1999?
Offer a terse response. 10.33. What is the ratio of the Aid flow (current US$) in Mali in 1993 to that in 1999?
Your answer should be compact. 0.51. What is the ratio of the Aid flow (current US$) of Ukraine in 1993 to that in 1999?
Make the answer very short. 7.91. What is the ratio of the Aid flow (current US$) of Grenada in 1994 to that in 1995?
Your answer should be very brief. 1.12. What is the ratio of the Aid flow (current US$) in Mali in 1994 to that in 1995?
Ensure brevity in your answer.  0.56. What is the ratio of the Aid flow (current US$) of Ukraine in 1994 to that in 1995?
Provide a short and direct response. 2.48. What is the ratio of the Aid flow (current US$) in Grenada in 1994 to that in 1996?
Your answer should be very brief. 2.71. What is the ratio of the Aid flow (current US$) in Mali in 1994 to that in 1996?
Make the answer very short. 0.39. What is the ratio of the Aid flow (current US$) of Ukraine in 1994 to that in 1996?
Offer a very short reply. 2.05. What is the ratio of the Aid flow (current US$) of Grenada in 1994 to that in 1997?
Provide a succinct answer. 6.33. What is the ratio of the Aid flow (current US$) of Mali in 1994 to that in 1997?
Your response must be concise. 0.46. What is the ratio of the Aid flow (current US$) of Ukraine in 1994 to that in 1997?
Your answer should be very brief. 3.89. What is the ratio of the Aid flow (current US$) in Equatorial Guinea in 1994 to that in 1999?
Offer a terse response. 1. What is the ratio of the Aid flow (current US$) of Grenada in 1994 to that in 1999?
Your answer should be compact. 6.33. What is the ratio of the Aid flow (current US$) in Mali in 1994 to that in 1999?
Ensure brevity in your answer.  0.53. What is the ratio of the Aid flow (current US$) in Ukraine in 1994 to that in 1999?
Offer a very short reply. 4.7. What is the ratio of the Aid flow (current US$) of Equatorial Guinea in 1995 to that in 1996?
Ensure brevity in your answer.  2.33. What is the ratio of the Aid flow (current US$) of Grenada in 1995 to that in 1996?
Ensure brevity in your answer.  2.43. What is the ratio of the Aid flow (current US$) of Mali in 1995 to that in 1996?
Offer a very short reply. 0.7. What is the ratio of the Aid flow (current US$) in Ukraine in 1995 to that in 1996?
Your response must be concise. 0.83. What is the ratio of the Aid flow (current US$) in Grenada in 1995 to that in 1997?
Offer a terse response. 5.67. What is the ratio of the Aid flow (current US$) of Mali in 1995 to that in 1997?
Your answer should be compact. 0.83. What is the ratio of the Aid flow (current US$) of Ukraine in 1995 to that in 1997?
Offer a terse response. 1.57. What is the ratio of the Aid flow (current US$) in Grenada in 1995 to that in 1999?
Keep it short and to the point. 5.67. What is the ratio of the Aid flow (current US$) of Mali in 1995 to that in 1999?
Your answer should be very brief. 0.95. What is the ratio of the Aid flow (current US$) in Ukraine in 1995 to that in 1999?
Offer a very short reply. 1.9. What is the ratio of the Aid flow (current US$) in Equatorial Guinea in 1996 to that in 1997?
Offer a terse response. 0.43. What is the ratio of the Aid flow (current US$) of Grenada in 1996 to that in 1997?
Offer a very short reply. 2.33. What is the ratio of the Aid flow (current US$) in Mali in 1996 to that in 1997?
Make the answer very short. 1.18. What is the ratio of the Aid flow (current US$) of Ukraine in 1996 to that in 1997?
Provide a short and direct response. 1.9. What is the ratio of the Aid flow (current US$) of Equatorial Guinea in 1996 to that in 1999?
Provide a short and direct response. 0.5. What is the ratio of the Aid flow (current US$) of Grenada in 1996 to that in 1999?
Your answer should be very brief. 2.33. What is the ratio of the Aid flow (current US$) of Mali in 1996 to that in 1999?
Give a very brief answer. 1.35. What is the ratio of the Aid flow (current US$) in Ukraine in 1996 to that in 1999?
Your answer should be very brief. 2.29. What is the ratio of the Aid flow (current US$) of Mali in 1997 to that in 1999?
Provide a short and direct response. 1.14. What is the ratio of the Aid flow (current US$) of Ukraine in 1997 to that in 1999?
Make the answer very short. 1.21. What is the difference between the highest and the second highest Aid flow (current US$) in Equatorial Guinea?
Ensure brevity in your answer.  3.80e+05. What is the difference between the highest and the second highest Aid flow (current US$) in Grenada?
Offer a very short reply. 1.10e+05. What is the difference between the highest and the second highest Aid flow (current US$) in Mali?
Provide a short and direct response. 1.00e+07. What is the difference between the highest and the second highest Aid flow (current US$) of Ukraine?
Your response must be concise. 3.05e+08. What is the difference between the highest and the lowest Aid flow (current US$) in Equatorial Guinea?
Provide a succinct answer. 4.20e+05. What is the difference between the highest and the lowest Aid flow (current US$) of Grenada?
Offer a terse response. 2.80e+05. What is the difference between the highest and the lowest Aid flow (current US$) in Mali?
Your answer should be compact. 4.16e+07. What is the difference between the highest and the lowest Aid flow (current US$) of Ukraine?
Offer a very short reply. 5.09e+08. 